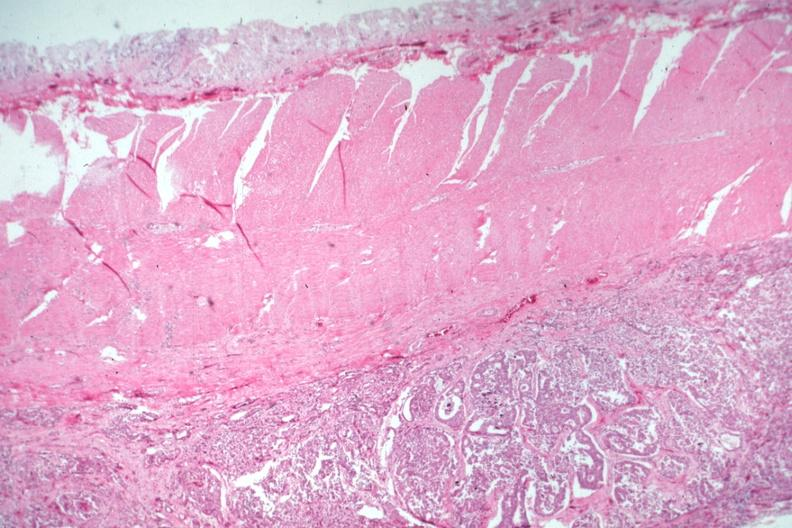what is present?
Answer the question using a single word or phrase. Metastatic carcinoma 